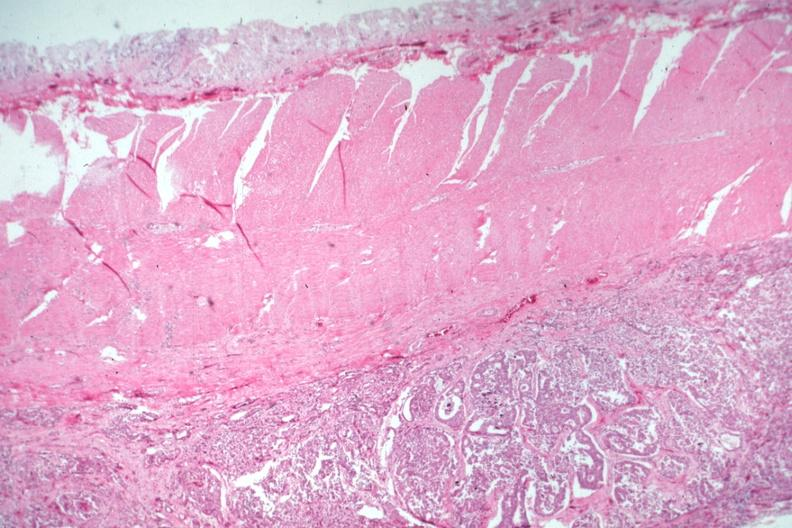what is present?
Answer the question using a single word or phrase. Metastatic carcinoma 